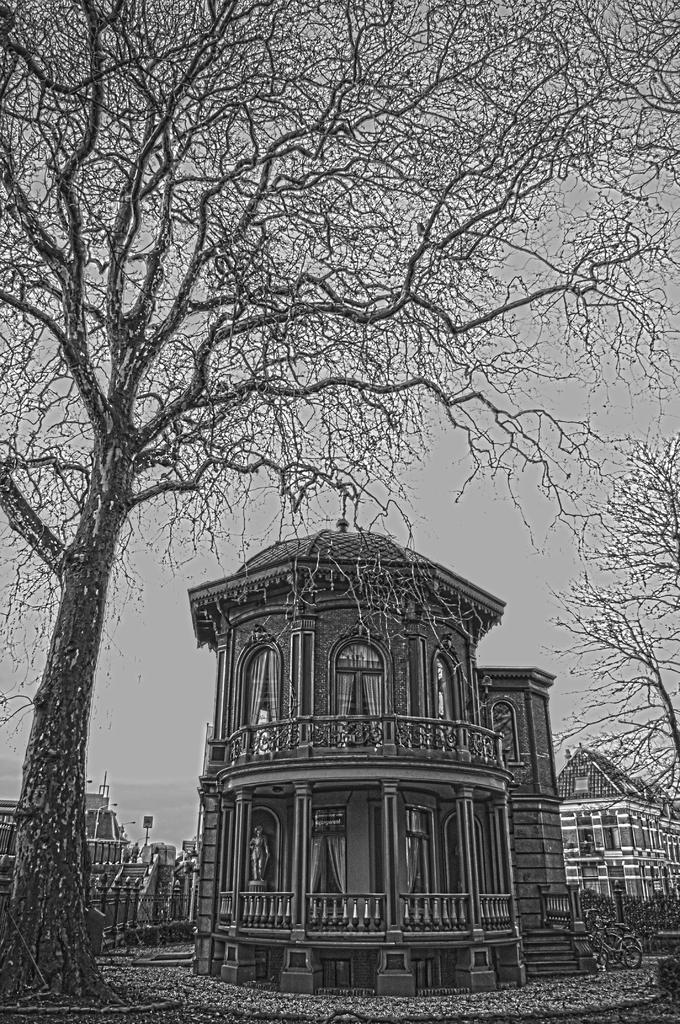Can you describe this image briefly? This image seems to be an edited image. In the middle there are buildings, trees, bicycle, railing, land. In the background there is sky. 